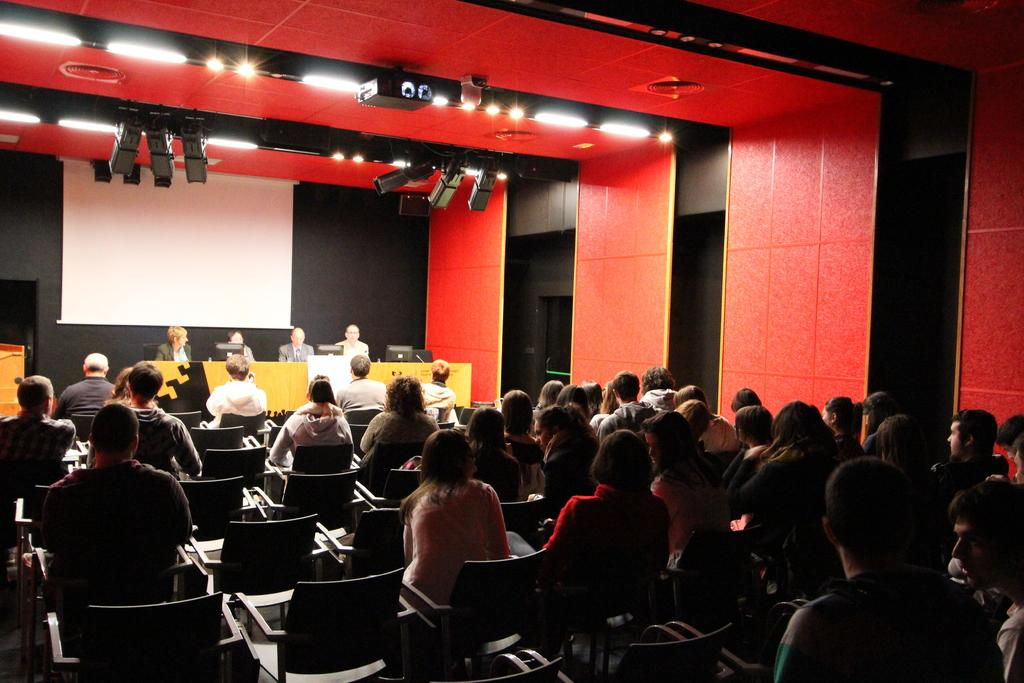What is happening in the image? There is a group of people sitting in the image. Where are the other people in the image located? There are people sitting on a stage in the background. What is at the top of the image? There is a screen at the top of the image. Can you describe any other elements in the image? There is a light visible in the image. How many trees can be seen in the image? There are no trees visible in the image. Can you describe the woman standing in the front row of the audience? There is no woman standing in the front row of the audience, as the image only shows people sitting. 